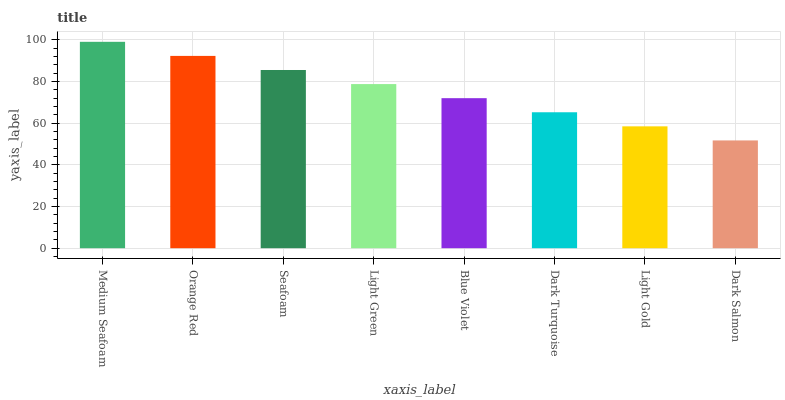Is Dark Salmon the minimum?
Answer yes or no. Yes. Is Medium Seafoam the maximum?
Answer yes or no. Yes. Is Orange Red the minimum?
Answer yes or no. No. Is Orange Red the maximum?
Answer yes or no. No. Is Medium Seafoam greater than Orange Red?
Answer yes or no. Yes. Is Orange Red less than Medium Seafoam?
Answer yes or no. Yes. Is Orange Red greater than Medium Seafoam?
Answer yes or no. No. Is Medium Seafoam less than Orange Red?
Answer yes or no. No. Is Light Green the high median?
Answer yes or no. Yes. Is Blue Violet the low median?
Answer yes or no. Yes. Is Seafoam the high median?
Answer yes or no. No. Is Light Green the low median?
Answer yes or no. No. 